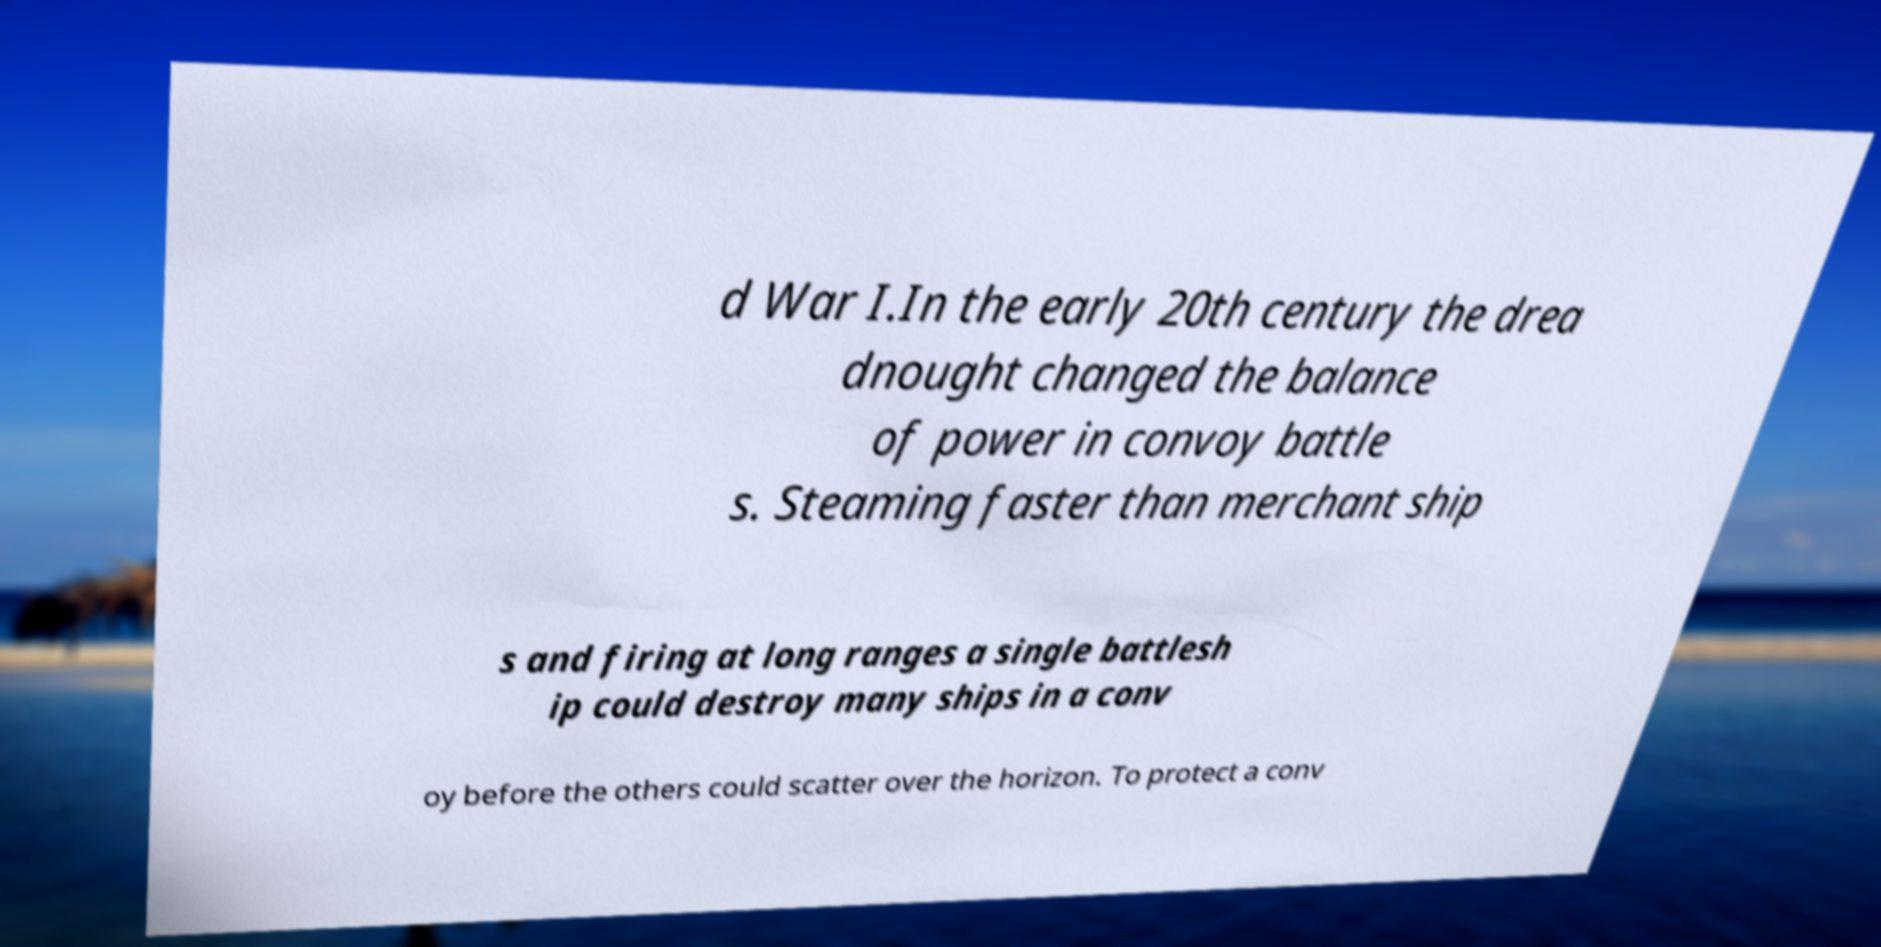Please read and relay the text visible in this image. What does it say? d War I.In the early 20th century the drea dnought changed the balance of power in convoy battle s. Steaming faster than merchant ship s and firing at long ranges a single battlesh ip could destroy many ships in a conv oy before the others could scatter over the horizon. To protect a conv 